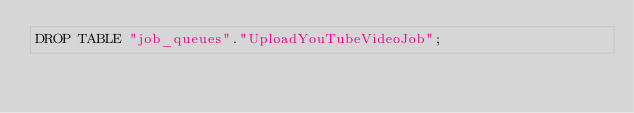Convert code to text. <code><loc_0><loc_0><loc_500><loc_500><_SQL_>DROP TABLE "job_queues"."UploadYouTubeVideoJob";
</code> 